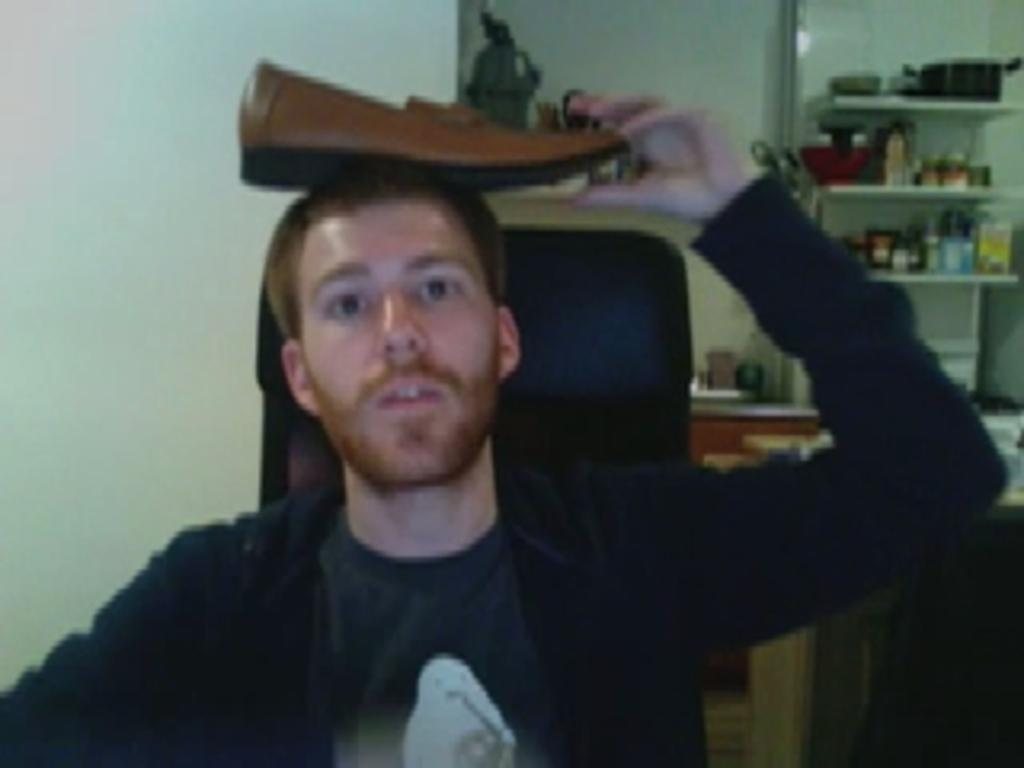What is the person in the image holding? The person is holding a shoe in the image. What can be seen on the shelves in the background of the image? There are vessels and jars on the shelves in the background of the image. What else is visible in the background of the image? There are other objects visible in the background of the image. What is one of the features of the setting in the image? There is a wall in the image. What type of story is being told by the lamp in the image? There is: There is no lamp present in the image, so it cannot be used to tell a story. 